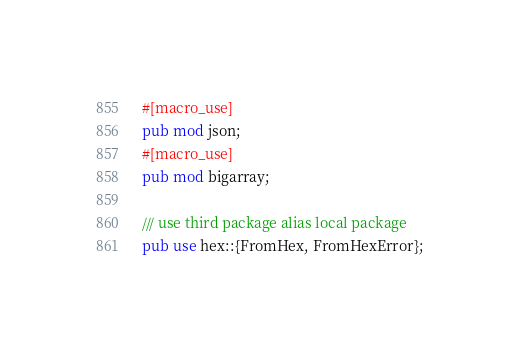<code> <loc_0><loc_0><loc_500><loc_500><_Rust_>#[macro_use]
pub mod json;
#[macro_use]
pub mod bigarray;

/// use third package alias local package
pub use hex::{FromHex, FromHexError};</code> 